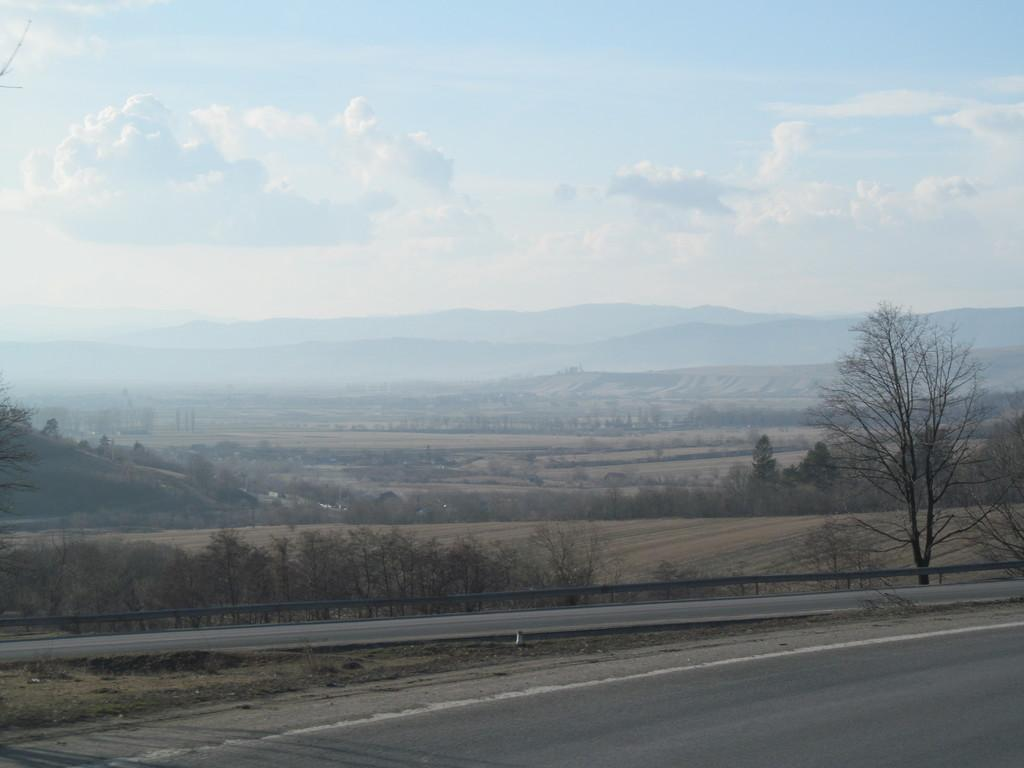What is the main feature of the image? There is a road in the image. What can be seen alongside the road? There is railing in the image. What type of natural elements are present in the image? There are trees in the image, and more trees are visible in the background. What can be seen in the distance in the image? There are mountains and clouds in the background of the image, and the sky is visible as well. What type of learning is taking place in the image? There is no indication of any learning taking place in the image. Can you tell me what question the trees are asking in the image? Trees do not ask questions, so this cannot be determined from the image. 